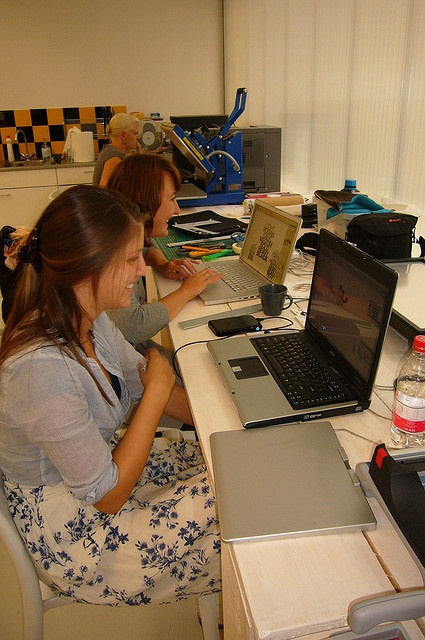Describe the objects in this image and their specific colors. I can see people in olive, tan, black, gray, and brown tones, laptop in olive, black, and maroon tones, laptop in olive, tan, and gray tones, people in olive, black, brown, maroon, and gray tones, and laptop in olive and tan tones in this image. 